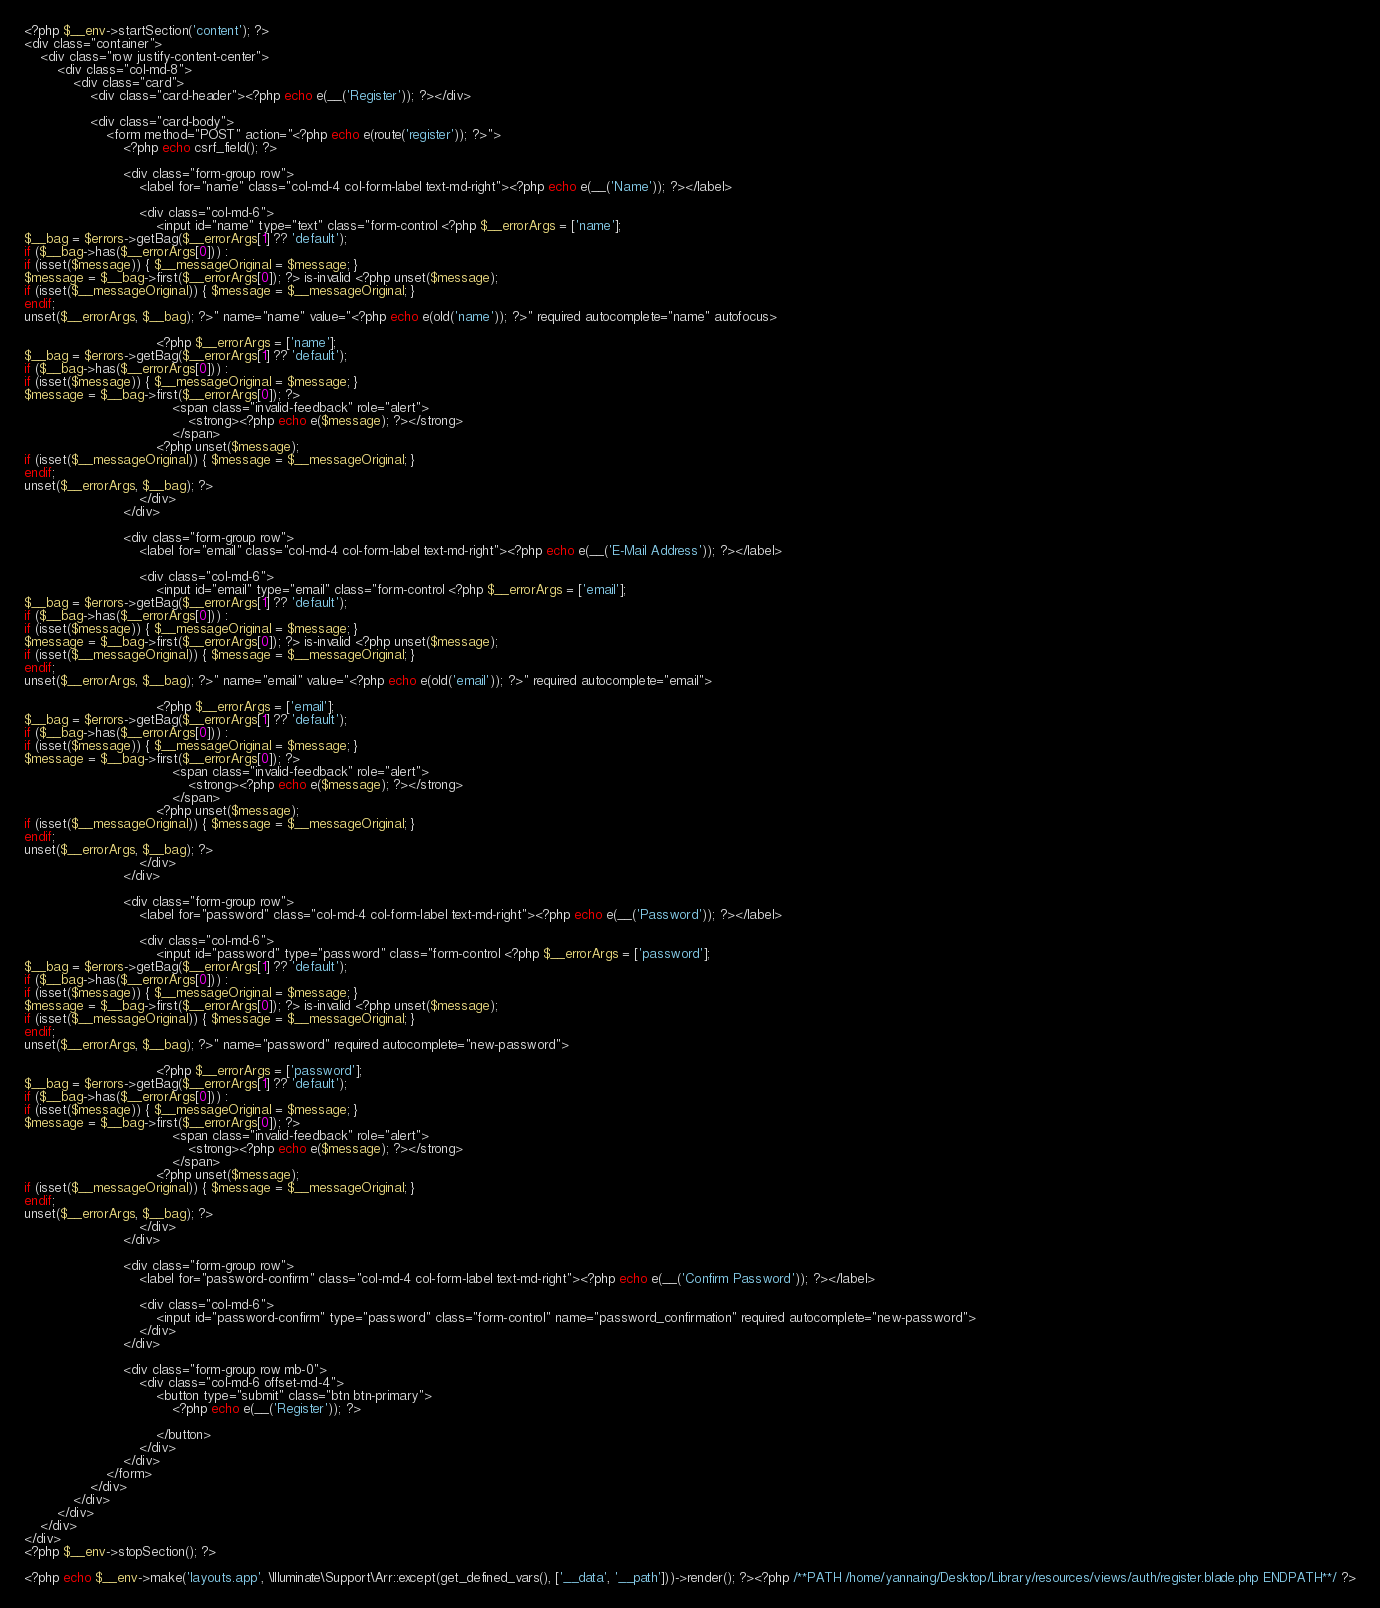Convert code to text. <code><loc_0><loc_0><loc_500><loc_500><_PHP_><?php $__env->startSection('content'); ?>
<div class="container">
    <div class="row justify-content-center">
        <div class="col-md-8">
            <div class="card">
                <div class="card-header"><?php echo e(__('Register')); ?></div>

                <div class="card-body">
                    <form method="POST" action="<?php echo e(route('register')); ?>">
                        <?php echo csrf_field(); ?>

                        <div class="form-group row">
                            <label for="name" class="col-md-4 col-form-label text-md-right"><?php echo e(__('Name')); ?></label>

                            <div class="col-md-6">
                                <input id="name" type="text" class="form-control <?php $__errorArgs = ['name'];
$__bag = $errors->getBag($__errorArgs[1] ?? 'default');
if ($__bag->has($__errorArgs[0])) :
if (isset($message)) { $__messageOriginal = $message; }
$message = $__bag->first($__errorArgs[0]); ?> is-invalid <?php unset($message);
if (isset($__messageOriginal)) { $message = $__messageOriginal; }
endif;
unset($__errorArgs, $__bag); ?>" name="name" value="<?php echo e(old('name')); ?>" required autocomplete="name" autofocus>

                                <?php $__errorArgs = ['name'];
$__bag = $errors->getBag($__errorArgs[1] ?? 'default');
if ($__bag->has($__errorArgs[0])) :
if (isset($message)) { $__messageOriginal = $message; }
$message = $__bag->first($__errorArgs[0]); ?>
                                    <span class="invalid-feedback" role="alert">
                                        <strong><?php echo e($message); ?></strong>
                                    </span>
                                <?php unset($message);
if (isset($__messageOriginal)) { $message = $__messageOriginal; }
endif;
unset($__errorArgs, $__bag); ?>
                            </div>
                        </div>

                        <div class="form-group row">
                            <label for="email" class="col-md-4 col-form-label text-md-right"><?php echo e(__('E-Mail Address')); ?></label>

                            <div class="col-md-6">
                                <input id="email" type="email" class="form-control <?php $__errorArgs = ['email'];
$__bag = $errors->getBag($__errorArgs[1] ?? 'default');
if ($__bag->has($__errorArgs[0])) :
if (isset($message)) { $__messageOriginal = $message; }
$message = $__bag->first($__errorArgs[0]); ?> is-invalid <?php unset($message);
if (isset($__messageOriginal)) { $message = $__messageOriginal; }
endif;
unset($__errorArgs, $__bag); ?>" name="email" value="<?php echo e(old('email')); ?>" required autocomplete="email">

                                <?php $__errorArgs = ['email'];
$__bag = $errors->getBag($__errorArgs[1] ?? 'default');
if ($__bag->has($__errorArgs[0])) :
if (isset($message)) { $__messageOriginal = $message; }
$message = $__bag->first($__errorArgs[0]); ?>
                                    <span class="invalid-feedback" role="alert">
                                        <strong><?php echo e($message); ?></strong>
                                    </span>
                                <?php unset($message);
if (isset($__messageOriginal)) { $message = $__messageOriginal; }
endif;
unset($__errorArgs, $__bag); ?>
                            </div>
                        </div>

                        <div class="form-group row">
                            <label for="password" class="col-md-4 col-form-label text-md-right"><?php echo e(__('Password')); ?></label>

                            <div class="col-md-6">
                                <input id="password" type="password" class="form-control <?php $__errorArgs = ['password'];
$__bag = $errors->getBag($__errorArgs[1] ?? 'default');
if ($__bag->has($__errorArgs[0])) :
if (isset($message)) { $__messageOriginal = $message; }
$message = $__bag->first($__errorArgs[0]); ?> is-invalid <?php unset($message);
if (isset($__messageOriginal)) { $message = $__messageOriginal; }
endif;
unset($__errorArgs, $__bag); ?>" name="password" required autocomplete="new-password">

                                <?php $__errorArgs = ['password'];
$__bag = $errors->getBag($__errorArgs[1] ?? 'default');
if ($__bag->has($__errorArgs[0])) :
if (isset($message)) { $__messageOriginal = $message; }
$message = $__bag->first($__errorArgs[0]); ?>
                                    <span class="invalid-feedback" role="alert">
                                        <strong><?php echo e($message); ?></strong>
                                    </span>
                                <?php unset($message);
if (isset($__messageOriginal)) { $message = $__messageOriginal; }
endif;
unset($__errorArgs, $__bag); ?>
                            </div>
                        </div>

                        <div class="form-group row">
                            <label for="password-confirm" class="col-md-4 col-form-label text-md-right"><?php echo e(__('Confirm Password')); ?></label>

                            <div class="col-md-6">
                                <input id="password-confirm" type="password" class="form-control" name="password_confirmation" required autocomplete="new-password">
                            </div>
                        </div>

                        <div class="form-group row mb-0">
                            <div class="col-md-6 offset-md-4">
                                <button type="submit" class="btn btn-primary">
                                    <?php echo e(__('Register')); ?>

                                </button>
                            </div>
                        </div>
                    </form>
                </div>
            </div>
        </div>
    </div>
</div>
<?php $__env->stopSection(); ?>

<?php echo $__env->make('layouts.app', \Illuminate\Support\Arr::except(get_defined_vars(), ['__data', '__path']))->render(); ?><?php /**PATH /home/yannaing/Desktop/Library/resources/views/auth/register.blade.php ENDPATH**/ ?></code> 